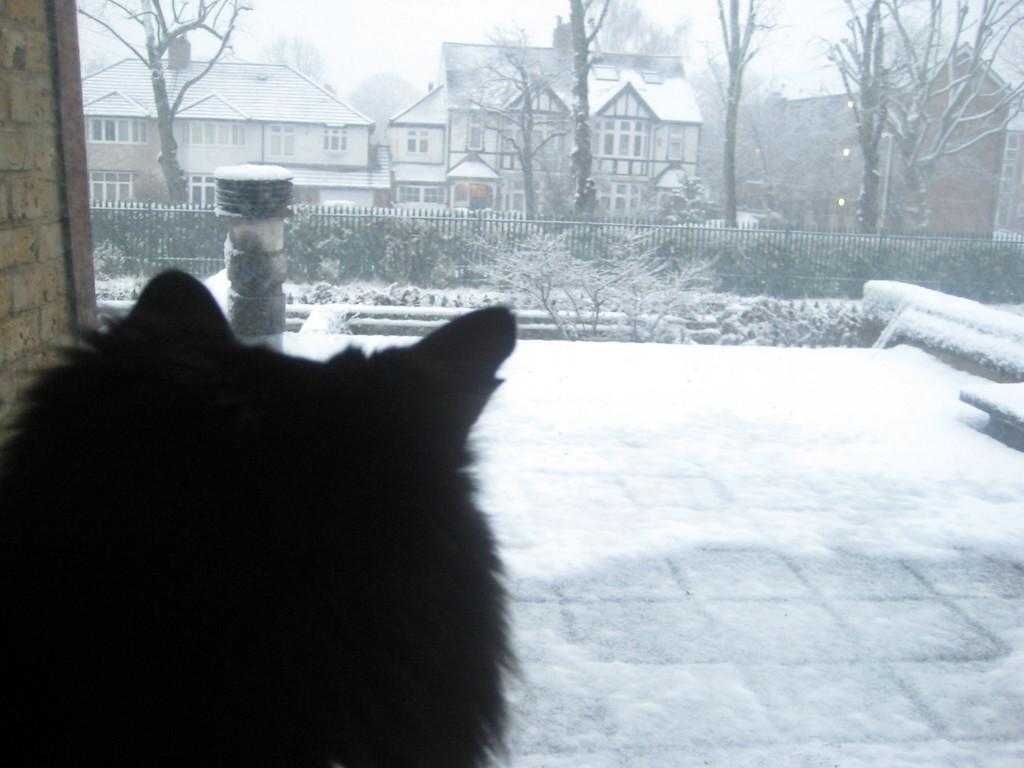What type of animal can be seen in the image? There is an animal in the image, but its specific type cannot be determined from the provided facts. What can be seen in the background of the image? There are trees and buildings with windows in the background of the image. What feature is present in the image that might be used for safety or support? There is railing in the image. What is the overall weather condition in the image? There is snow everywhere in the image, indicating a cold and snowy environment. How many snails can be seen crawling on the animal in the image? There is no mention of snails in the image, so it is not possible to determine their presence or number. What type of home is visible in the image? The provided facts do not mention a home in the image. Is the animal wearing a scarf in the image? There is no mention of a scarf or any clothing on the animal in the image. 